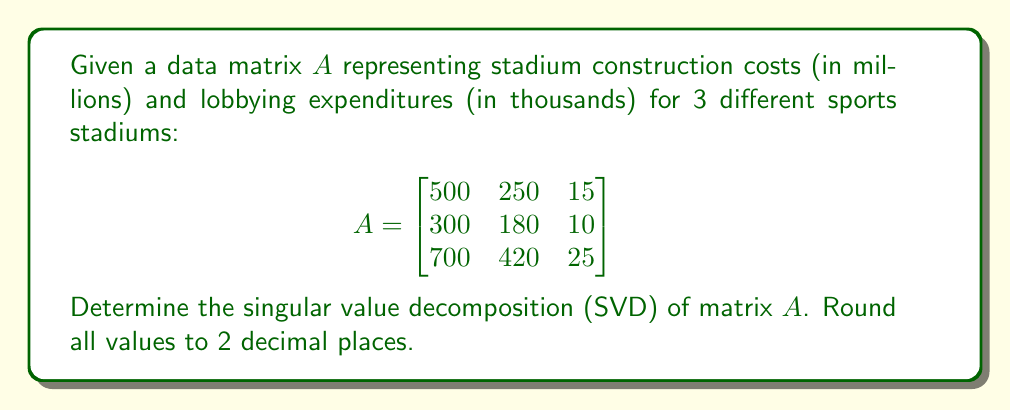What is the answer to this math problem? To find the singular value decomposition of matrix $A$, we need to determine $U$, $\Sigma$, and $V^T$ such that $A = U\Sigma V^T$.

Step 1: Calculate $A^TA$ and $AA^T$
$$A^TA = \begin{bmatrix}
830000 & 498000 & 29750 \\
498000 & 298900 & 17850 \\
29750 & 17850 & 1066
\end{bmatrix}$$

$$AA^T = \begin{bmatrix}
315225 & 189300 & 441525 \\
189300 & 113700 & 265200 \\
441525 & 265200 & 618625
\end{bmatrix}$$

Step 2: Find eigenvalues of $A^TA$ (same as non-zero eigenvalues of $AA^T$)
Solving $\det(A^TA - \lambda I) = 0$, we get:
$\lambda_1 \approx 1129893.76$
$\lambda_2 \approx 70.24$
$\lambda_3 \approx 2.00$

Step 3: Calculate singular values
$\sigma_1 = \sqrt{\lambda_1} \approx 1063.01$
$\sigma_2 = \sqrt{\lambda_2} \approx 8.38$
$\sigma_3 = \sqrt{\lambda_3} \approx 1.41$

Step 4: Find eigenvectors of $A^TA$ (right singular vectors)
$v_1 \approx [0.86, 0.51, 0.03]^T$
$v_2 \approx [-0.52, 0.85, 0.05]^T$
$v_3 \approx [-0.03, -0.05, 1.00]^T$

Step 5: Find left singular vectors
$u_1 = \frac{1}{\sigma_1}Av_1 \approx [0.59, 0.35, 0.72]^T$
$u_2 = \frac{1}{\sigma_2}Av_2 \approx [-0.71, 0.70, -0.01]^T$
$u_3 = \frac{1}{\sigma_3}Av_3 \approx [-0.38, -0.62, 0.69]^T$

Step 6: Construct $U$, $\Sigma$, and $V^T$
$$U = \begin{bmatrix}
0.59 & -0.71 & -0.38 \\
0.35 & 0.70 & -0.62 \\
0.72 & -0.01 & 0.69
\end{bmatrix}$$

$$\Sigma = \begin{bmatrix}
1063.01 & 0 & 0 \\
0 & 8.38 & 0 \\
0 & 0 & 1.41
\end{bmatrix}$$

$$V^T = \begin{bmatrix}
0.86 & 0.51 & 0.03 \\
-0.52 & 0.85 & 0.05 \\
-0.03 & -0.05 & 1.00
\end{bmatrix}$$
Answer: $A = U\Sigma V^T$, where
$U \approx \begin{bmatrix}
0.59 & -0.71 & -0.38 \\
0.35 & 0.70 & -0.62 \\
0.72 & -0.01 & 0.69
\end{bmatrix}$,
$\Sigma \approx \begin{bmatrix}
1063.01 & 0 & 0 \\
0 & 8.38 & 0 \\
0 & 0 & 1.41
\end{bmatrix}$,
$V^T \approx \begin{bmatrix}
0.86 & 0.51 & 0.03 \\
-0.52 & 0.85 & 0.05 \\
-0.03 & -0.05 & 1.00
\end{bmatrix}$ 